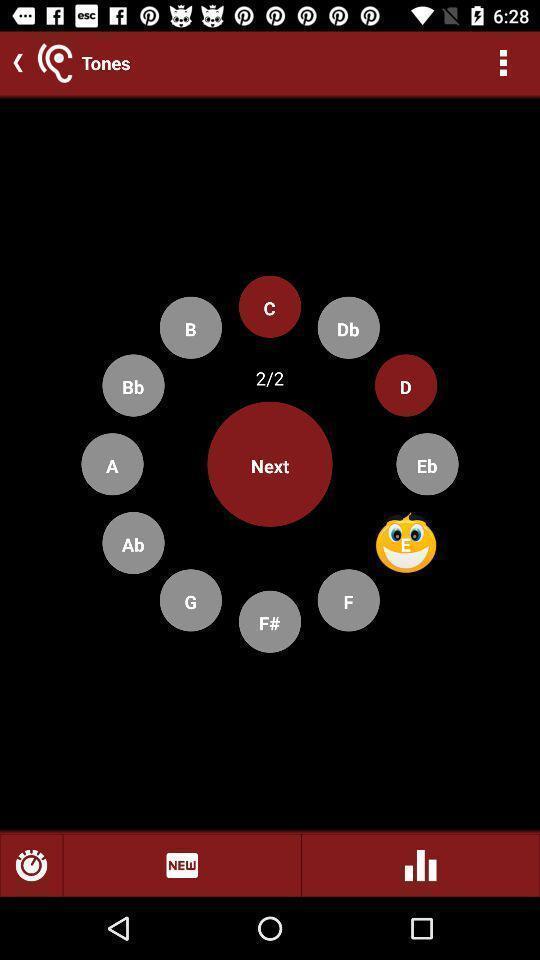Describe this image in words. Window displaying a music app. 